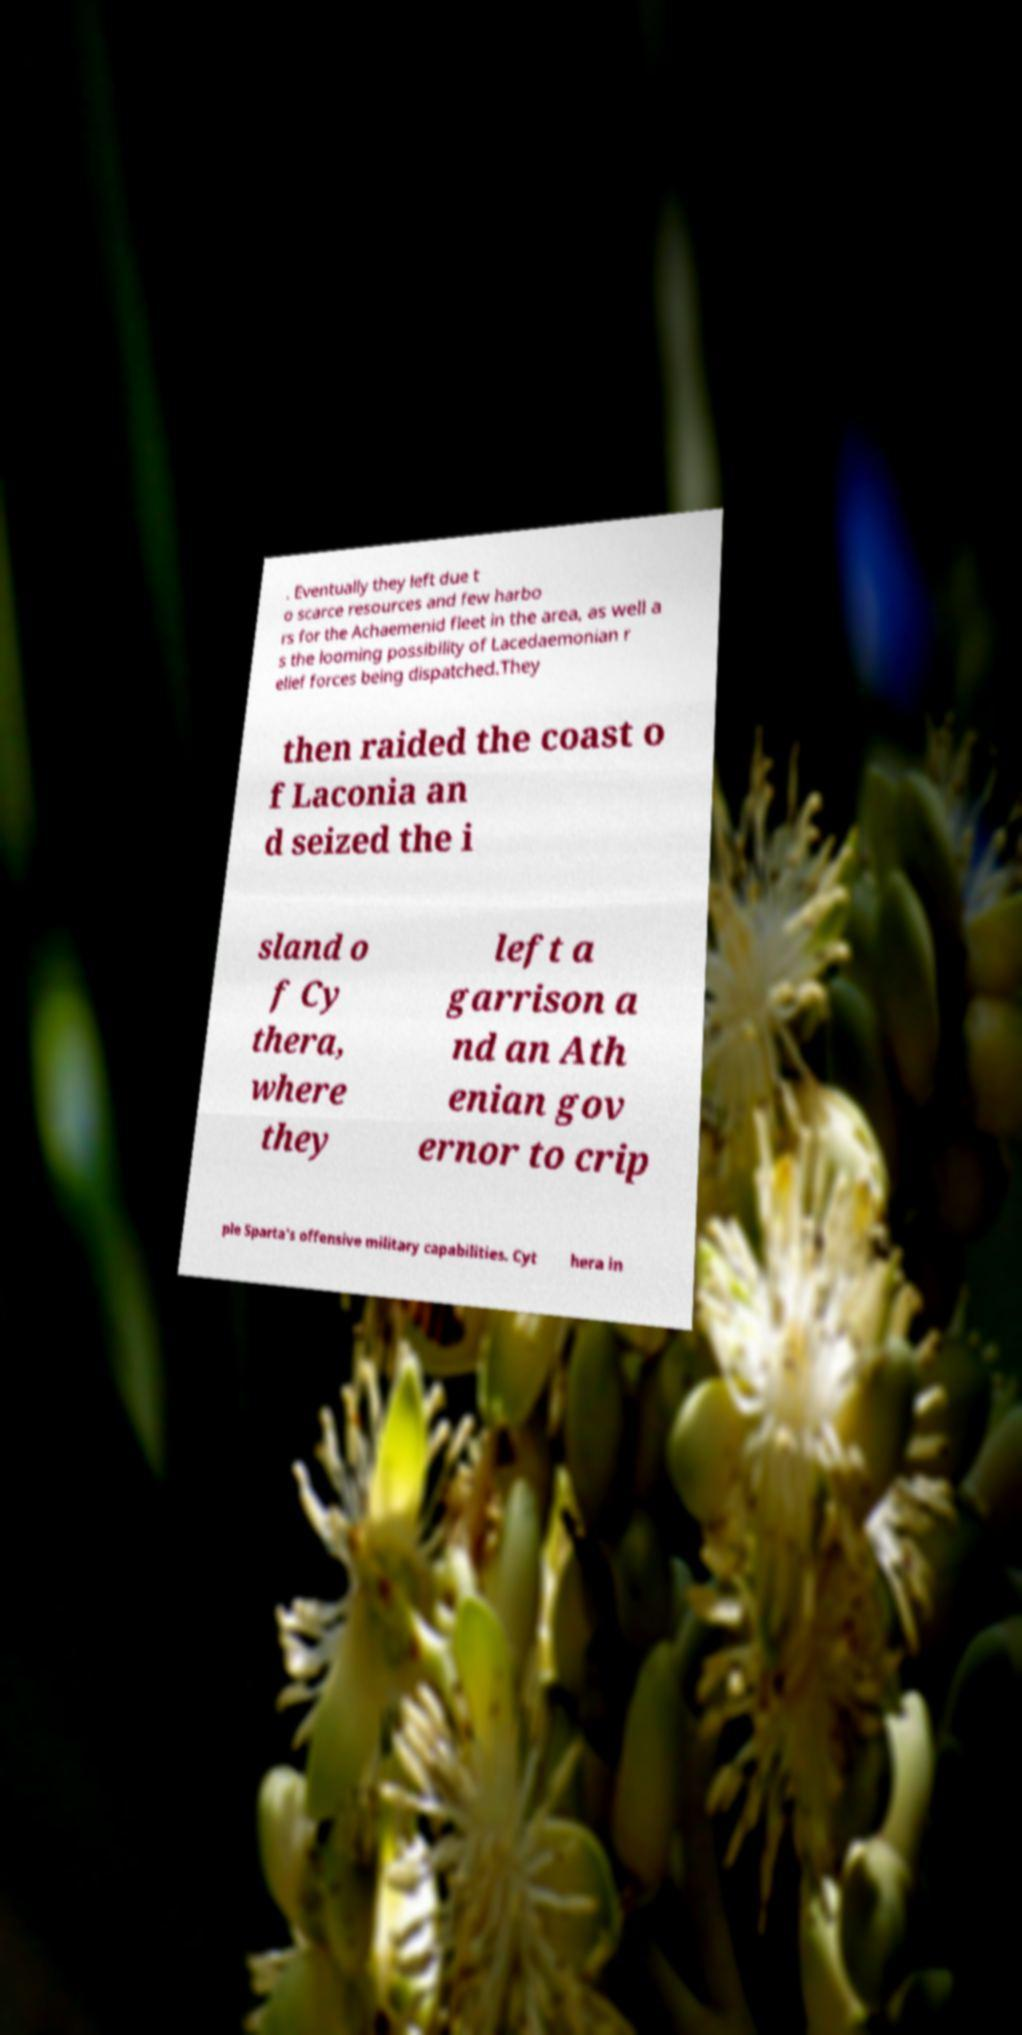Please identify and transcribe the text found in this image. . Eventually they left due t o scarce resources and few harbo rs for the Achaemenid fleet in the area, as well a s the looming possibility of Lacedaemonian r elief forces being dispatched.They then raided the coast o f Laconia an d seized the i sland o f Cy thera, where they left a garrison a nd an Ath enian gov ernor to crip ple Sparta's offensive military capabilities. Cyt hera in 